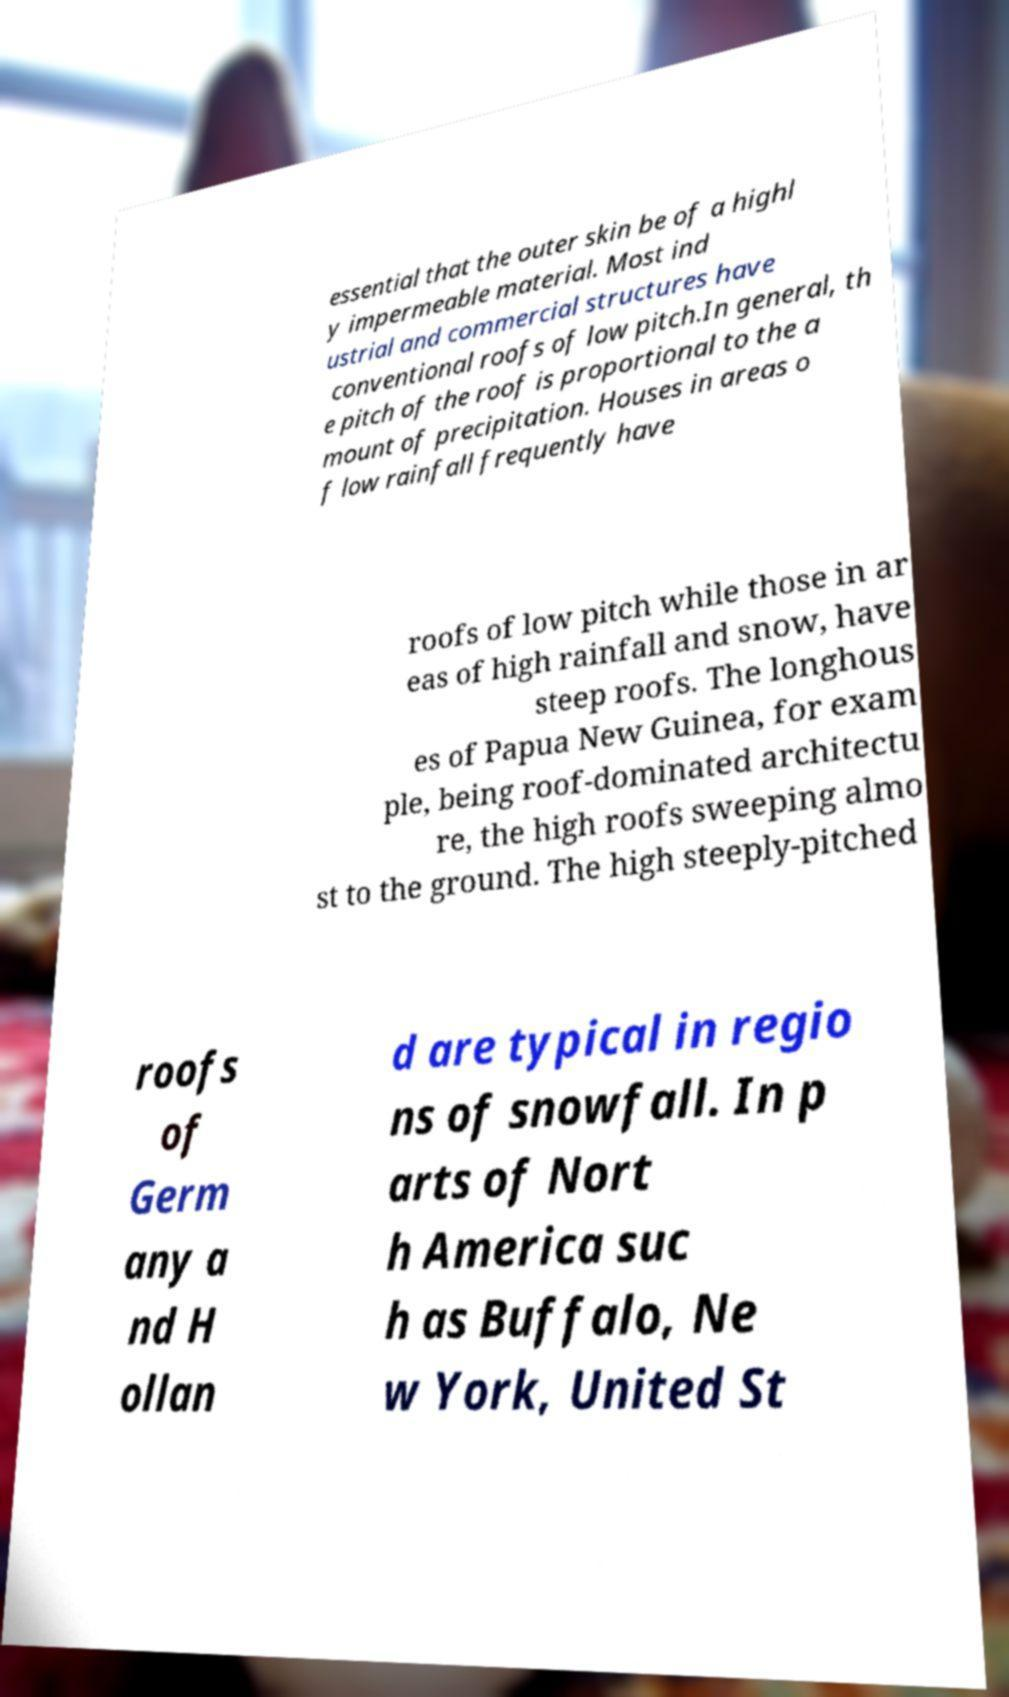For documentation purposes, I need the text within this image transcribed. Could you provide that? essential that the outer skin be of a highl y impermeable material. Most ind ustrial and commercial structures have conventional roofs of low pitch.In general, th e pitch of the roof is proportional to the a mount of precipitation. Houses in areas o f low rainfall frequently have roofs of low pitch while those in ar eas of high rainfall and snow, have steep roofs. The longhous es of Papua New Guinea, for exam ple, being roof-dominated architectu re, the high roofs sweeping almo st to the ground. The high steeply-pitched roofs of Germ any a nd H ollan d are typical in regio ns of snowfall. In p arts of Nort h America suc h as Buffalo, Ne w York, United St 